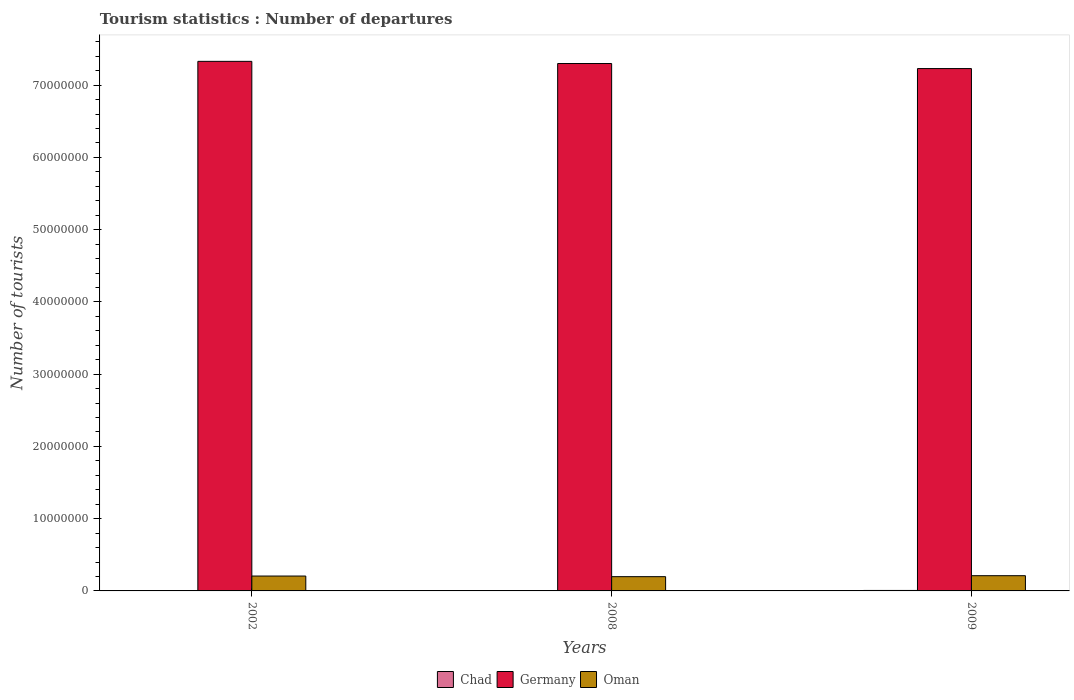How many groups of bars are there?
Make the answer very short. 3. Are the number of bars per tick equal to the number of legend labels?
Offer a terse response. Yes. Are the number of bars on each tick of the X-axis equal?
Ensure brevity in your answer.  Yes. How many bars are there on the 3rd tick from the left?
Ensure brevity in your answer.  3. How many bars are there on the 1st tick from the right?
Give a very brief answer. 3. In how many cases, is the number of bars for a given year not equal to the number of legend labels?
Give a very brief answer. 0. What is the number of tourist departures in Oman in 2009?
Your response must be concise. 2.11e+06. Across all years, what is the maximum number of tourist departures in Germany?
Provide a short and direct response. 7.33e+07. Across all years, what is the minimum number of tourist departures in Oman?
Your response must be concise. 1.97e+06. What is the total number of tourist departures in Chad in the graph?
Offer a terse response. 1.47e+05. What is the difference between the number of tourist departures in Oman in 2008 and that in 2009?
Your response must be concise. -1.35e+05. What is the difference between the number of tourist departures in Germany in 2009 and the number of tourist departures in Oman in 2002?
Give a very brief answer. 7.02e+07. What is the average number of tourist departures in Germany per year?
Offer a very short reply. 7.29e+07. In the year 2002, what is the difference between the number of tourist departures in Oman and number of tourist departures in Chad?
Provide a succinct answer. 2.04e+06. What is the ratio of the number of tourist departures in Chad in 2008 to that in 2009?
Your answer should be compact. 0.88. Is the number of tourist departures in Germany in 2002 less than that in 2008?
Your answer should be compact. No. Is the difference between the number of tourist departures in Oman in 2002 and 2008 greater than the difference between the number of tourist departures in Chad in 2002 and 2008?
Your response must be concise. Yes. What is the difference between the highest and the second highest number of tourist departures in Oman?
Your response must be concise. 4.80e+04. What is the difference between the highest and the lowest number of tourist departures in Oman?
Provide a succinct answer. 1.35e+05. In how many years, is the number of tourist departures in Germany greater than the average number of tourist departures in Germany taken over all years?
Make the answer very short. 2. What does the 1st bar from the left in 2009 represents?
Your answer should be very brief. Chad. What does the 3rd bar from the right in 2009 represents?
Offer a very short reply. Chad. Is it the case that in every year, the sum of the number of tourist departures in Germany and number of tourist departures in Oman is greater than the number of tourist departures in Chad?
Provide a short and direct response. Yes. Are all the bars in the graph horizontal?
Provide a short and direct response. No. How many years are there in the graph?
Offer a very short reply. 3. What is the difference between two consecutive major ticks on the Y-axis?
Give a very brief answer. 1.00e+07. Are the values on the major ticks of Y-axis written in scientific E-notation?
Your response must be concise. No. Where does the legend appear in the graph?
Offer a very short reply. Bottom center. How many legend labels are there?
Give a very brief answer. 3. What is the title of the graph?
Give a very brief answer. Tourism statistics : Number of departures. Does "Cabo Verde" appear as one of the legend labels in the graph?
Offer a very short reply. No. What is the label or title of the Y-axis?
Offer a terse response. Number of tourists. What is the Number of tourists in Chad in 2002?
Your response must be concise. 2.30e+04. What is the Number of tourists in Germany in 2002?
Provide a succinct answer. 7.33e+07. What is the Number of tourists in Oman in 2002?
Your response must be concise. 2.06e+06. What is the Number of tourists in Chad in 2008?
Provide a short and direct response. 5.80e+04. What is the Number of tourists in Germany in 2008?
Offer a very short reply. 7.30e+07. What is the Number of tourists in Oman in 2008?
Keep it short and to the point. 1.97e+06. What is the Number of tourists of Chad in 2009?
Your response must be concise. 6.60e+04. What is the Number of tourists in Germany in 2009?
Provide a succinct answer. 7.23e+07. What is the Number of tourists of Oman in 2009?
Your answer should be compact. 2.11e+06. Across all years, what is the maximum Number of tourists of Chad?
Give a very brief answer. 6.60e+04. Across all years, what is the maximum Number of tourists in Germany?
Give a very brief answer. 7.33e+07. Across all years, what is the maximum Number of tourists of Oman?
Ensure brevity in your answer.  2.11e+06. Across all years, what is the minimum Number of tourists in Chad?
Make the answer very short. 2.30e+04. Across all years, what is the minimum Number of tourists of Germany?
Offer a terse response. 7.23e+07. Across all years, what is the minimum Number of tourists in Oman?
Make the answer very short. 1.97e+06. What is the total Number of tourists in Chad in the graph?
Your answer should be compact. 1.47e+05. What is the total Number of tourists of Germany in the graph?
Make the answer very short. 2.19e+08. What is the total Number of tourists of Oman in the graph?
Provide a succinct answer. 6.14e+06. What is the difference between the Number of tourists of Chad in 2002 and that in 2008?
Your response must be concise. -3.50e+04. What is the difference between the Number of tourists of Germany in 2002 and that in 2008?
Make the answer very short. 3.00e+05. What is the difference between the Number of tourists in Oman in 2002 and that in 2008?
Offer a very short reply. 8.70e+04. What is the difference between the Number of tourists of Chad in 2002 and that in 2009?
Offer a very short reply. -4.30e+04. What is the difference between the Number of tourists in Oman in 2002 and that in 2009?
Your answer should be very brief. -4.80e+04. What is the difference between the Number of tourists in Chad in 2008 and that in 2009?
Keep it short and to the point. -8000. What is the difference between the Number of tourists in Germany in 2008 and that in 2009?
Offer a very short reply. 7.00e+05. What is the difference between the Number of tourists in Oman in 2008 and that in 2009?
Provide a short and direct response. -1.35e+05. What is the difference between the Number of tourists in Chad in 2002 and the Number of tourists in Germany in 2008?
Make the answer very short. -7.30e+07. What is the difference between the Number of tourists in Chad in 2002 and the Number of tourists in Oman in 2008?
Your answer should be very brief. -1.95e+06. What is the difference between the Number of tourists in Germany in 2002 and the Number of tourists in Oman in 2008?
Make the answer very short. 7.13e+07. What is the difference between the Number of tourists of Chad in 2002 and the Number of tourists of Germany in 2009?
Offer a very short reply. -7.23e+07. What is the difference between the Number of tourists of Chad in 2002 and the Number of tourists of Oman in 2009?
Make the answer very short. -2.08e+06. What is the difference between the Number of tourists in Germany in 2002 and the Number of tourists in Oman in 2009?
Give a very brief answer. 7.12e+07. What is the difference between the Number of tourists of Chad in 2008 and the Number of tourists of Germany in 2009?
Your answer should be very brief. -7.22e+07. What is the difference between the Number of tourists in Chad in 2008 and the Number of tourists in Oman in 2009?
Make the answer very short. -2.05e+06. What is the difference between the Number of tourists in Germany in 2008 and the Number of tourists in Oman in 2009?
Give a very brief answer. 7.09e+07. What is the average Number of tourists of Chad per year?
Give a very brief answer. 4.90e+04. What is the average Number of tourists of Germany per year?
Give a very brief answer. 7.29e+07. What is the average Number of tourists of Oman per year?
Provide a short and direct response. 2.05e+06. In the year 2002, what is the difference between the Number of tourists in Chad and Number of tourists in Germany?
Provide a short and direct response. -7.33e+07. In the year 2002, what is the difference between the Number of tourists of Chad and Number of tourists of Oman?
Your answer should be very brief. -2.04e+06. In the year 2002, what is the difference between the Number of tourists of Germany and Number of tourists of Oman?
Provide a succinct answer. 7.12e+07. In the year 2008, what is the difference between the Number of tourists of Chad and Number of tourists of Germany?
Keep it short and to the point. -7.29e+07. In the year 2008, what is the difference between the Number of tourists in Chad and Number of tourists in Oman?
Offer a terse response. -1.92e+06. In the year 2008, what is the difference between the Number of tourists of Germany and Number of tourists of Oman?
Offer a terse response. 7.10e+07. In the year 2009, what is the difference between the Number of tourists of Chad and Number of tourists of Germany?
Your response must be concise. -7.22e+07. In the year 2009, what is the difference between the Number of tourists in Chad and Number of tourists in Oman?
Your answer should be very brief. -2.04e+06. In the year 2009, what is the difference between the Number of tourists of Germany and Number of tourists of Oman?
Provide a succinct answer. 7.02e+07. What is the ratio of the Number of tourists in Chad in 2002 to that in 2008?
Your answer should be very brief. 0.4. What is the ratio of the Number of tourists of Oman in 2002 to that in 2008?
Ensure brevity in your answer.  1.04. What is the ratio of the Number of tourists in Chad in 2002 to that in 2009?
Your response must be concise. 0.35. What is the ratio of the Number of tourists in Germany in 2002 to that in 2009?
Offer a terse response. 1.01. What is the ratio of the Number of tourists in Oman in 2002 to that in 2009?
Provide a short and direct response. 0.98. What is the ratio of the Number of tourists in Chad in 2008 to that in 2009?
Your response must be concise. 0.88. What is the ratio of the Number of tourists in Germany in 2008 to that in 2009?
Your answer should be very brief. 1.01. What is the ratio of the Number of tourists in Oman in 2008 to that in 2009?
Give a very brief answer. 0.94. What is the difference between the highest and the second highest Number of tourists of Chad?
Give a very brief answer. 8000. What is the difference between the highest and the second highest Number of tourists of Oman?
Ensure brevity in your answer.  4.80e+04. What is the difference between the highest and the lowest Number of tourists in Chad?
Offer a very short reply. 4.30e+04. What is the difference between the highest and the lowest Number of tourists of Oman?
Offer a very short reply. 1.35e+05. 